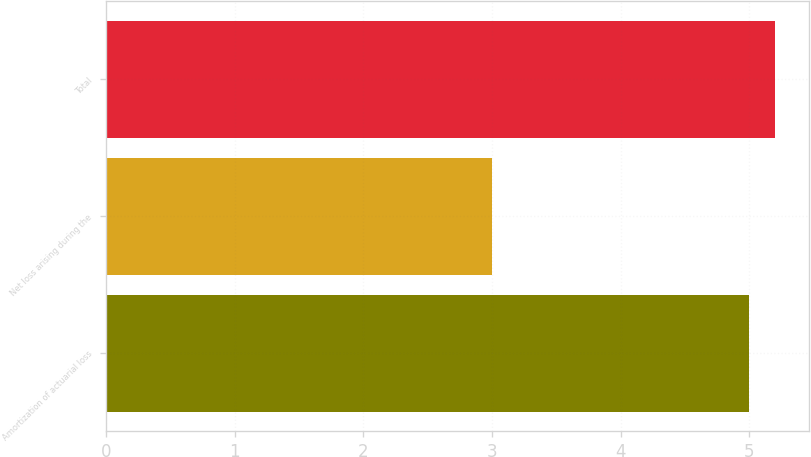<chart> <loc_0><loc_0><loc_500><loc_500><bar_chart><fcel>Amortization of actuarial loss<fcel>Net loss arising during the<fcel>Total<nl><fcel>5<fcel>3<fcel>5.2<nl></chart> 